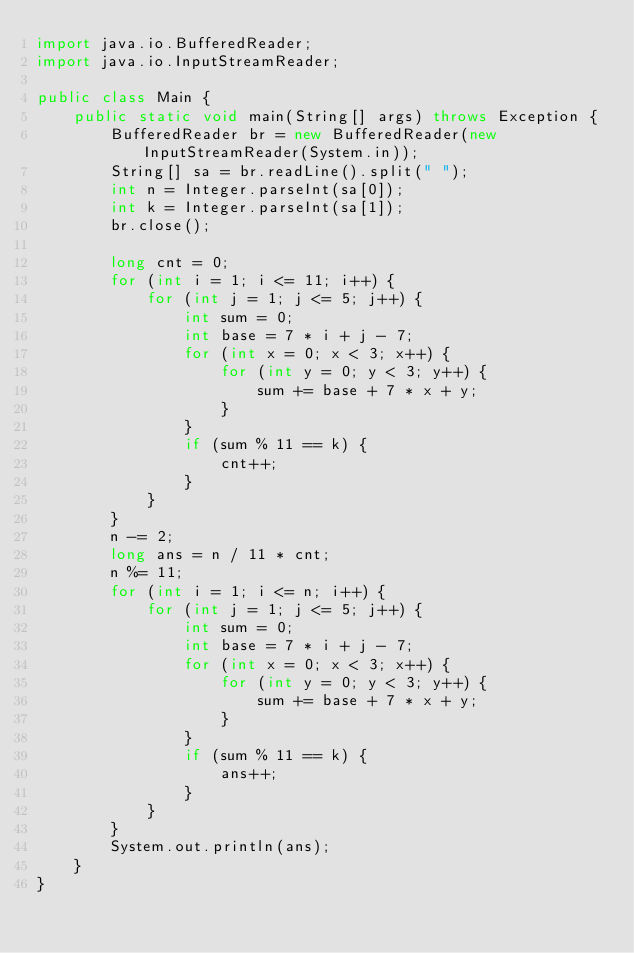<code> <loc_0><loc_0><loc_500><loc_500><_Java_>import java.io.BufferedReader;
import java.io.InputStreamReader;

public class Main {
	public static void main(String[] args) throws Exception {
		BufferedReader br = new BufferedReader(new InputStreamReader(System.in));
		String[] sa = br.readLine().split(" ");
		int n = Integer.parseInt(sa[0]);
		int k = Integer.parseInt(sa[1]);
		br.close();

		long cnt = 0;
		for (int i = 1; i <= 11; i++) {
			for (int j = 1; j <= 5; j++) {
				int sum = 0;
				int base = 7 * i + j - 7;
				for (int x = 0; x < 3; x++) {
					for (int y = 0; y < 3; y++) {
						sum += base + 7 * x + y;
					}
				}
				if (sum % 11 == k) {
					cnt++;
				}
			}
		}
		n -= 2;
		long ans = n / 11 * cnt;
		n %= 11;
		for (int i = 1; i <= n; i++) {
			for (int j = 1; j <= 5; j++) {
				int sum = 0;
				int base = 7 * i + j - 7;
				for (int x = 0; x < 3; x++) {
					for (int y = 0; y < 3; y++) {
						sum += base + 7 * x + y;
					}
				}
				if (sum % 11 == k) {
					ans++;
				}
			}
		}
		System.out.println(ans);
	}
}
</code> 